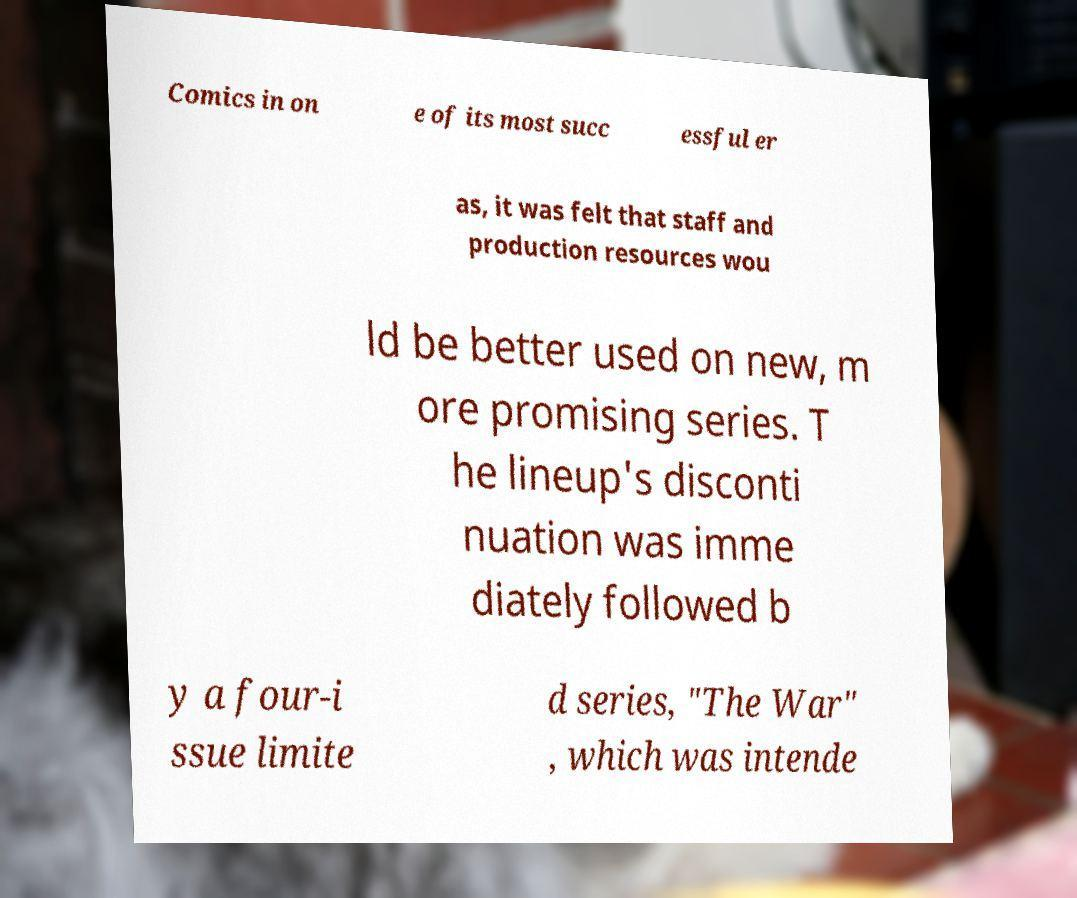Could you assist in decoding the text presented in this image and type it out clearly? Comics in on e of its most succ essful er as, it was felt that staff and production resources wou ld be better used on new, m ore promising series. T he lineup's disconti nuation was imme diately followed b y a four-i ssue limite d series, "The War" , which was intende 